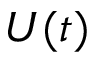Convert formula to latex. <formula><loc_0><loc_0><loc_500><loc_500>U ( t )</formula> 